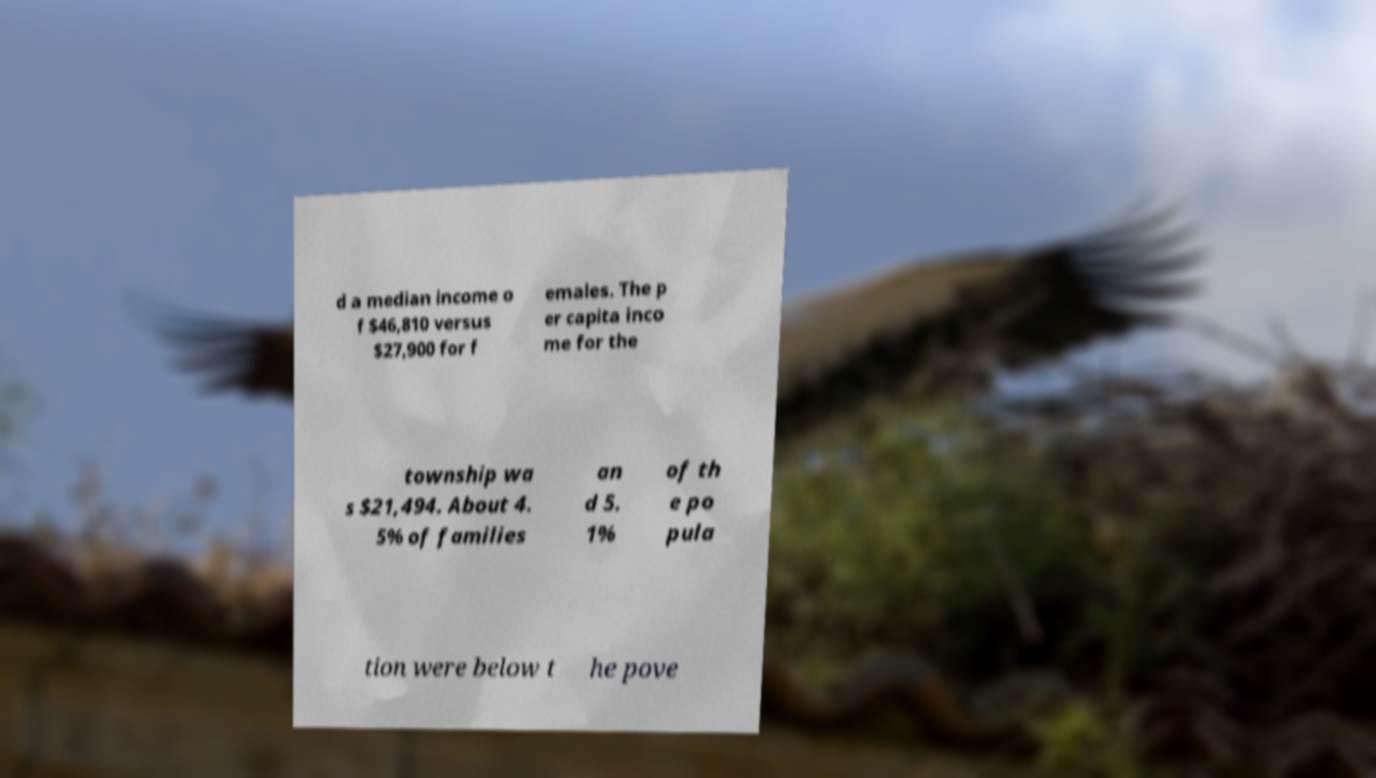Could you assist in decoding the text presented in this image and type it out clearly? d a median income o f $46,810 versus $27,900 for f emales. The p er capita inco me for the township wa s $21,494. About 4. 5% of families an d 5. 1% of th e po pula tion were below t he pove 